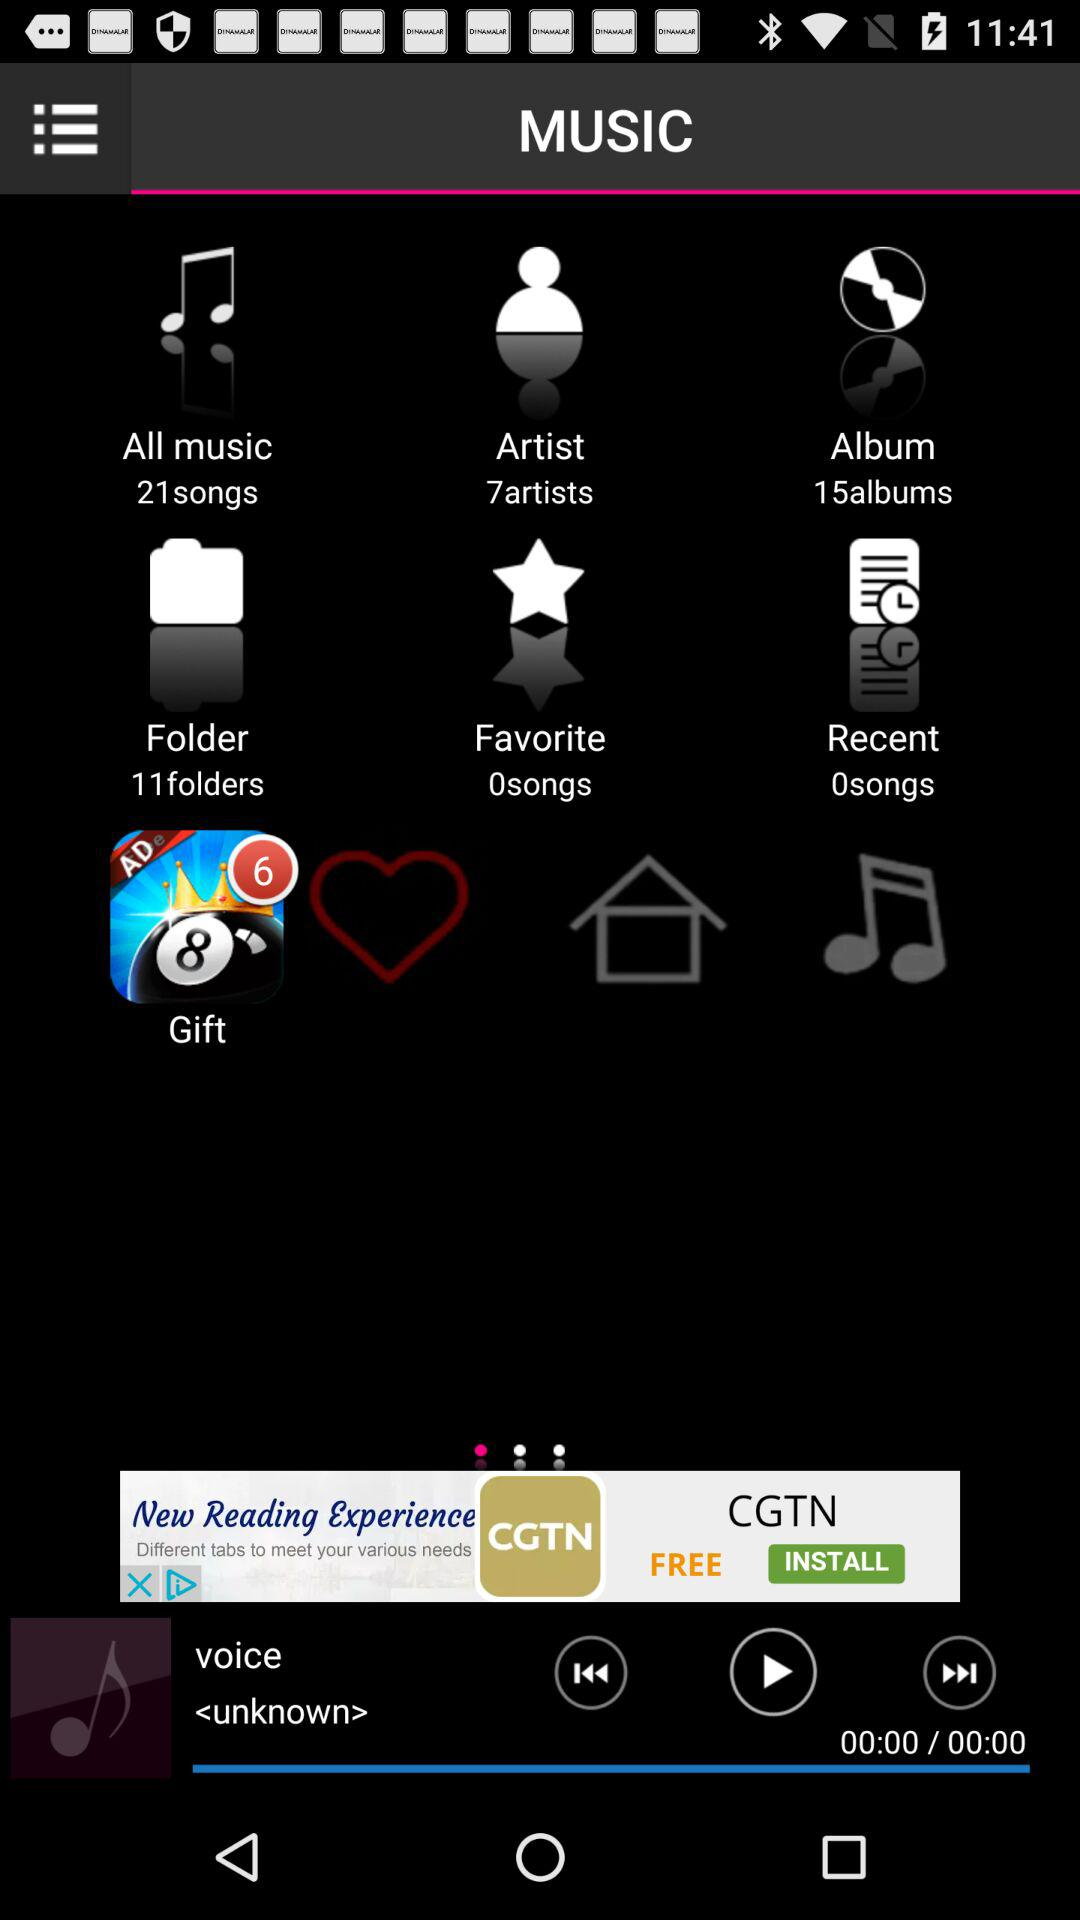How many more folders are there than albums?
Answer the question using a single word or phrase. 4 